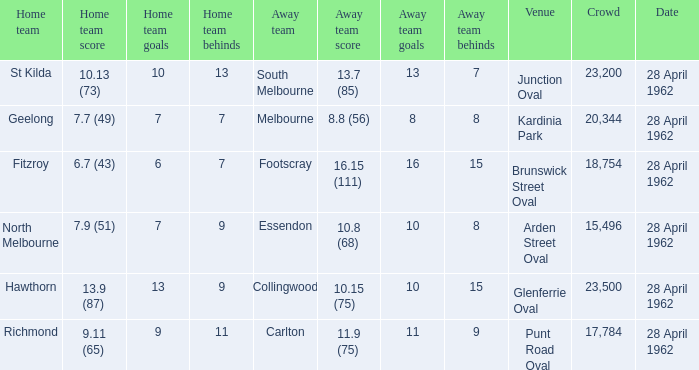What was the crowd size when there was a home team score of 10.13 (73)? 23200.0. Could you help me parse every detail presented in this table? {'header': ['Home team', 'Home team score', 'Home team goals', 'Home team behinds', 'Away team', 'Away team score', 'Away team goals', 'Away team behinds', 'Venue', 'Crowd', 'Date'], 'rows': [['St Kilda', '10.13 (73)', '10', '13', 'South Melbourne', '13.7 (85)', '13', '7', 'Junction Oval', '23,200', '28 April 1962'], ['Geelong', '7.7 (49)', '7', '7', 'Melbourne', '8.8 (56)', '8', '8', 'Kardinia Park', '20,344', '28 April 1962'], ['Fitzroy', '6.7 (43)', '6', '7', 'Footscray', '16.15 (111)', '16', '15', 'Brunswick Street Oval', '18,754', '28 April 1962'], ['North Melbourne', '7.9 (51)', '7', '9', 'Essendon', '10.8 (68)', '10', '8', 'Arden Street Oval', '15,496', '28 April 1962'], ['Hawthorn', '13.9 (87)', '13', '9', 'Collingwood', '10.15 (75)', '10', '15', 'Glenferrie Oval', '23,500', '28 April 1962'], ['Richmond', '9.11 (65)', '9', '11', 'Carlton', '11.9 (75)', '11', '9', 'Punt Road Oval', '17,784', '28 April 1962']]} 